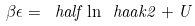Convert formula to latex. <formula><loc_0><loc_0><loc_500><loc_500>\beta \epsilon = \ h a l f \ln \ h a a k { 2 } + U</formula> 